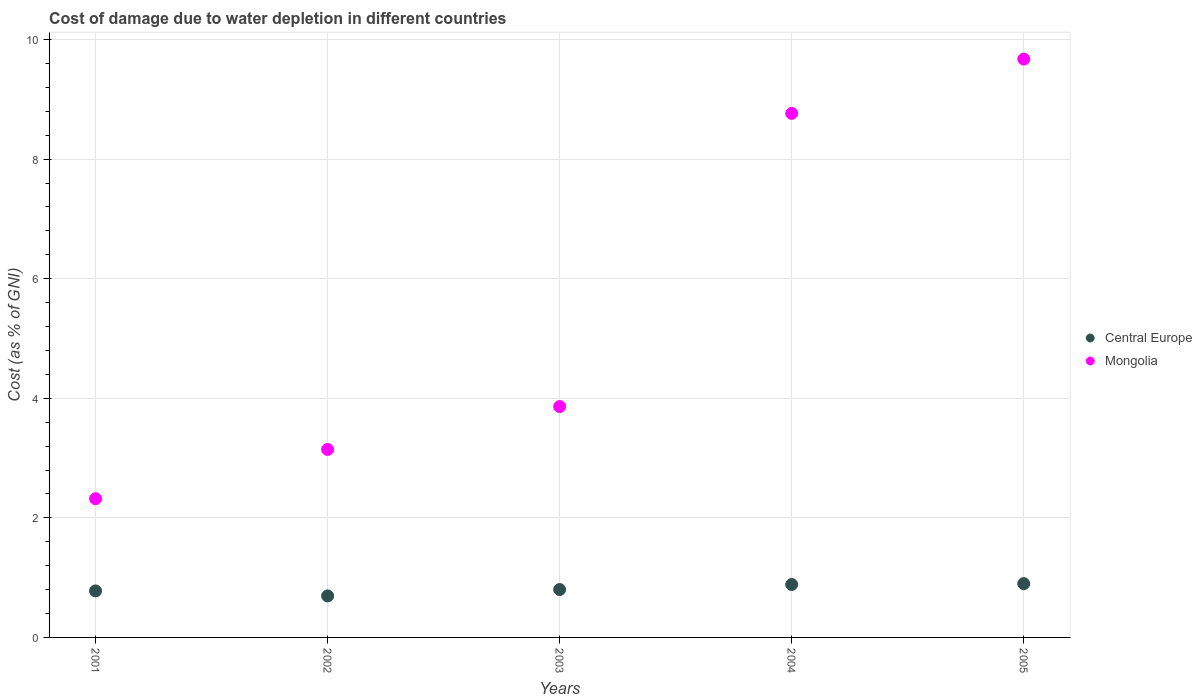How many different coloured dotlines are there?
Your response must be concise. 2. Is the number of dotlines equal to the number of legend labels?
Your answer should be very brief. Yes. What is the cost of damage caused due to water depletion in Mongolia in 2004?
Your answer should be very brief. 8.77. Across all years, what is the maximum cost of damage caused due to water depletion in Central Europe?
Your answer should be very brief. 0.9. Across all years, what is the minimum cost of damage caused due to water depletion in Mongolia?
Make the answer very short. 2.32. In which year was the cost of damage caused due to water depletion in Central Europe minimum?
Your answer should be compact. 2002. What is the total cost of damage caused due to water depletion in Central Europe in the graph?
Give a very brief answer. 4.06. What is the difference between the cost of damage caused due to water depletion in Central Europe in 2002 and that in 2004?
Offer a terse response. -0.19. What is the difference between the cost of damage caused due to water depletion in Central Europe in 2004 and the cost of damage caused due to water depletion in Mongolia in 2005?
Your answer should be very brief. -8.79. What is the average cost of damage caused due to water depletion in Central Europe per year?
Your response must be concise. 0.81. In the year 2001, what is the difference between the cost of damage caused due to water depletion in Mongolia and cost of damage caused due to water depletion in Central Europe?
Provide a succinct answer. 1.54. What is the ratio of the cost of damage caused due to water depletion in Mongolia in 2002 to that in 2003?
Keep it short and to the point. 0.81. Is the difference between the cost of damage caused due to water depletion in Mongolia in 2003 and 2005 greater than the difference between the cost of damage caused due to water depletion in Central Europe in 2003 and 2005?
Ensure brevity in your answer.  No. What is the difference between the highest and the second highest cost of damage caused due to water depletion in Central Europe?
Ensure brevity in your answer.  0.01. What is the difference between the highest and the lowest cost of damage caused due to water depletion in Mongolia?
Your answer should be compact. 7.35. In how many years, is the cost of damage caused due to water depletion in Central Europe greater than the average cost of damage caused due to water depletion in Central Europe taken over all years?
Your answer should be very brief. 2. Does the cost of damage caused due to water depletion in Central Europe monotonically increase over the years?
Your response must be concise. No. Is the cost of damage caused due to water depletion in Mongolia strictly less than the cost of damage caused due to water depletion in Central Europe over the years?
Give a very brief answer. No. How many dotlines are there?
Provide a short and direct response. 2. How many years are there in the graph?
Provide a succinct answer. 5. Where does the legend appear in the graph?
Your answer should be very brief. Center right. How many legend labels are there?
Provide a succinct answer. 2. How are the legend labels stacked?
Ensure brevity in your answer.  Vertical. What is the title of the graph?
Provide a succinct answer. Cost of damage due to water depletion in different countries. Does "Micronesia" appear as one of the legend labels in the graph?
Make the answer very short. No. What is the label or title of the X-axis?
Offer a very short reply. Years. What is the label or title of the Y-axis?
Give a very brief answer. Cost (as % of GNI). What is the Cost (as % of GNI) in Central Europe in 2001?
Your response must be concise. 0.78. What is the Cost (as % of GNI) in Mongolia in 2001?
Provide a short and direct response. 2.32. What is the Cost (as % of GNI) in Central Europe in 2002?
Offer a very short reply. 0.69. What is the Cost (as % of GNI) in Mongolia in 2002?
Offer a very short reply. 3.14. What is the Cost (as % of GNI) in Central Europe in 2003?
Keep it short and to the point. 0.8. What is the Cost (as % of GNI) in Mongolia in 2003?
Offer a very short reply. 3.86. What is the Cost (as % of GNI) of Central Europe in 2004?
Make the answer very short. 0.89. What is the Cost (as % of GNI) of Mongolia in 2004?
Provide a succinct answer. 8.77. What is the Cost (as % of GNI) in Central Europe in 2005?
Give a very brief answer. 0.9. What is the Cost (as % of GNI) in Mongolia in 2005?
Offer a very short reply. 9.67. Across all years, what is the maximum Cost (as % of GNI) in Central Europe?
Make the answer very short. 0.9. Across all years, what is the maximum Cost (as % of GNI) of Mongolia?
Offer a very short reply. 9.67. Across all years, what is the minimum Cost (as % of GNI) in Central Europe?
Give a very brief answer. 0.69. Across all years, what is the minimum Cost (as % of GNI) in Mongolia?
Your response must be concise. 2.32. What is the total Cost (as % of GNI) of Central Europe in the graph?
Give a very brief answer. 4.06. What is the total Cost (as % of GNI) of Mongolia in the graph?
Ensure brevity in your answer.  27.77. What is the difference between the Cost (as % of GNI) in Central Europe in 2001 and that in 2002?
Keep it short and to the point. 0.08. What is the difference between the Cost (as % of GNI) of Mongolia in 2001 and that in 2002?
Offer a very short reply. -0.82. What is the difference between the Cost (as % of GNI) in Central Europe in 2001 and that in 2003?
Give a very brief answer. -0.02. What is the difference between the Cost (as % of GNI) in Mongolia in 2001 and that in 2003?
Your answer should be very brief. -1.54. What is the difference between the Cost (as % of GNI) in Central Europe in 2001 and that in 2004?
Offer a very short reply. -0.11. What is the difference between the Cost (as % of GNI) in Mongolia in 2001 and that in 2004?
Give a very brief answer. -6.45. What is the difference between the Cost (as % of GNI) in Central Europe in 2001 and that in 2005?
Your answer should be compact. -0.12. What is the difference between the Cost (as % of GNI) in Mongolia in 2001 and that in 2005?
Your response must be concise. -7.35. What is the difference between the Cost (as % of GNI) of Central Europe in 2002 and that in 2003?
Ensure brevity in your answer.  -0.11. What is the difference between the Cost (as % of GNI) of Mongolia in 2002 and that in 2003?
Provide a short and direct response. -0.72. What is the difference between the Cost (as % of GNI) in Central Europe in 2002 and that in 2004?
Offer a terse response. -0.19. What is the difference between the Cost (as % of GNI) of Mongolia in 2002 and that in 2004?
Ensure brevity in your answer.  -5.62. What is the difference between the Cost (as % of GNI) in Central Europe in 2002 and that in 2005?
Your answer should be very brief. -0.21. What is the difference between the Cost (as % of GNI) of Mongolia in 2002 and that in 2005?
Your answer should be compact. -6.53. What is the difference between the Cost (as % of GNI) in Central Europe in 2003 and that in 2004?
Your answer should be very brief. -0.08. What is the difference between the Cost (as % of GNI) of Mongolia in 2003 and that in 2004?
Your answer should be very brief. -4.9. What is the difference between the Cost (as % of GNI) in Central Europe in 2003 and that in 2005?
Ensure brevity in your answer.  -0.1. What is the difference between the Cost (as % of GNI) of Mongolia in 2003 and that in 2005?
Offer a terse response. -5.81. What is the difference between the Cost (as % of GNI) of Central Europe in 2004 and that in 2005?
Offer a terse response. -0.01. What is the difference between the Cost (as % of GNI) of Mongolia in 2004 and that in 2005?
Keep it short and to the point. -0.91. What is the difference between the Cost (as % of GNI) of Central Europe in 2001 and the Cost (as % of GNI) of Mongolia in 2002?
Your answer should be compact. -2.37. What is the difference between the Cost (as % of GNI) in Central Europe in 2001 and the Cost (as % of GNI) in Mongolia in 2003?
Ensure brevity in your answer.  -3.08. What is the difference between the Cost (as % of GNI) in Central Europe in 2001 and the Cost (as % of GNI) in Mongolia in 2004?
Your response must be concise. -7.99. What is the difference between the Cost (as % of GNI) in Central Europe in 2001 and the Cost (as % of GNI) in Mongolia in 2005?
Offer a terse response. -8.9. What is the difference between the Cost (as % of GNI) in Central Europe in 2002 and the Cost (as % of GNI) in Mongolia in 2003?
Provide a short and direct response. -3.17. What is the difference between the Cost (as % of GNI) of Central Europe in 2002 and the Cost (as % of GNI) of Mongolia in 2004?
Your answer should be compact. -8.07. What is the difference between the Cost (as % of GNI) in Central Europe in 2002 and the Cost (as % of GNI) in Mongolia in 2005?
Give a very brief answer. -8.98. What is the difference between the Cost (as % of GNI) in Central Europe in 2003 and the Cost (as % of GNI) in Mongolia in 2004?
Ensure brevity in your answer.  -7.96. What is the difference between the Cost (as % of GNI) of Central Europe in 2003 and the Cost (as % of GNI) of Mongolia in 2005?
Provide a succinct answer. -8.87. What is the difference between the Cost (as % of GNI) in Central Europe in 2004 and the Cost (as % of GNI) in Mongolia in 2005?
Make the answer very short. -8.79. What is the average Cost (as % of GNI) in Central Europe per year?
Offer a terse response. 0.81. What is the average Cost (as % of GNI) of Mongolia per year?
Your response must be concise. 5.55. In the year 2001, what is the difference between the Cost (as % of GNI) in Central Europe and Cost (as % of GNI) in Mongolia?
Provide a short and direct response. -1.54. In the year 2002, what is the difference between the Cost (as % of GNI) in Central Europe and Cost (as % of GNI) in Mongolia?
Your answer should be compact. -2.45. In the year 2003, what is the difference between the Cost (as % of GNI) in Central Europe and Cost (as % of GNI) in Mongolia?
Your answer should be very brief. -3.06. In the year 2004, what is the difference between the Cost (as % of GNI) in Central Europe and Cost (as % of GNI) in Mongolia?
Provide a succinct answer. -7.88. In the year 2005, what is the difference between the Cost (as % of GNI) in Central Europe and Cost (as % of GNI) in Mongolia?
Ensure brevity in your answer.  -8.77. What is the ratio of the Cost (as % of GNI) in Central Europe in 2001 to that in 2002?
Ensure brevity in your answer.  1.12. What is the ratio of the Cost (as % of GNI) in Mongolia in 2001 to that in 2002?
Give a very brief answer. 0.74. What is the ratio of the Cost (as % of GNI) of Central Europe in 2001 to that in 2003?
Offer a very short reply. 0.97. What is the ratio of the Cost (as % of GNI) in Mongolia in 2001 to that in 2003?
Offer a very short reply. 0.6. What is the ratio of the Cost (as % of GNI) of Central Europe in 2001 to that in 2004?
Ensure brevity in your answer.  0.88. What is the ratio of the Cost (as % of GNI) in Mongolia in 2001 to that in 2004?
Your answer should be very brief. 0.26. What is the ratio of the Cost (as % of GNI) of Central Europe in 2001 to that in 2005?
Give a very brief answer. 0.86. What is the ratio of the Cost (as % of GNI) in Mongolia in 2001 to that in 2005?
Keep it short and to the point. 0.24. What is the ratio of the Cost (as % of GNI) of Central Europe in 2002 to that in 2003?
Your response must be concise. 0.87. What is the ratio of the Cost (as % of GNI) of Mongolia in 2002 to that in 2003?
Provide a succinct answer. 0.81. What is the ratio of the Cost (as % of GNI) of Central Europe in 2002 to that in 2004?
Your response must be concise. 0.78. What is the ratio of the Cost (as % of GNI) in Mongolia in 2002 to that in 2004?
Your response must be concise. 0.36. What is the ratio of the Cost (as % of GNI) of Central Europe in 2002 to that in 2005?
Ensure brevity in your answer.  0.77. What is the ratio of the Cost (as % of GNI) in Mongolia in 2002 to that in 2005?
Offer a terse response. 0.33. What is the ratio of the Cost (as % of GNI) of Central Europe in 2003 to that in 2004?
Give a very brief answer. 0.9. What is the ratio of the Cost (as % of GNI) of Mongolia in 2003 to that in 2004?
Provide a short and direct response. 0.44. What is the ratio of the Cost (as % of GNI) of Central Europe in 2003 to that in 2005?
Keep it short and to the point. 0.89. What is the ratio of the Cost (as % of GNI) of Mongolia in 2003 to that in 2005?
Provide a short and direct response. 0.4. What is the ratio of the Cost (as % of GNI) in Central Europe in 2004 to that in 2005?
Make the answer very short. 0.98. What is the ratio of the Cost (as % of GNI) of Mongolia in 2004 to that in 2005?
Provide a short and direct response. 0.91. What is the difference between the highest and the second highest Cost (as % of GNI) of Central Europe?
Make the answer very short. 0.01. What is the difference between the highest and the second highest Cost (as % of GNI) of Mongolia?
Provide a short and direct response. 0.91. What is the difference between the highest and the lowest Cost (as % of GNI) of Central Europe?
Your response must be concise. 0.21. What is the difference between the highest and the lowest Cost (as % of GNI) in Mongolia?
Your response must be concise. 7.35. 